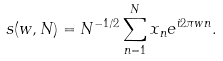<formula> <loc_0><loc_0><loc_500><loc_500>s ( w , N ) = N ^ { - 1 / 2 } \sum _ { n = 1 } ^ { N } x _ { n } e ^ { i 2 \pi w n } .</formula> 